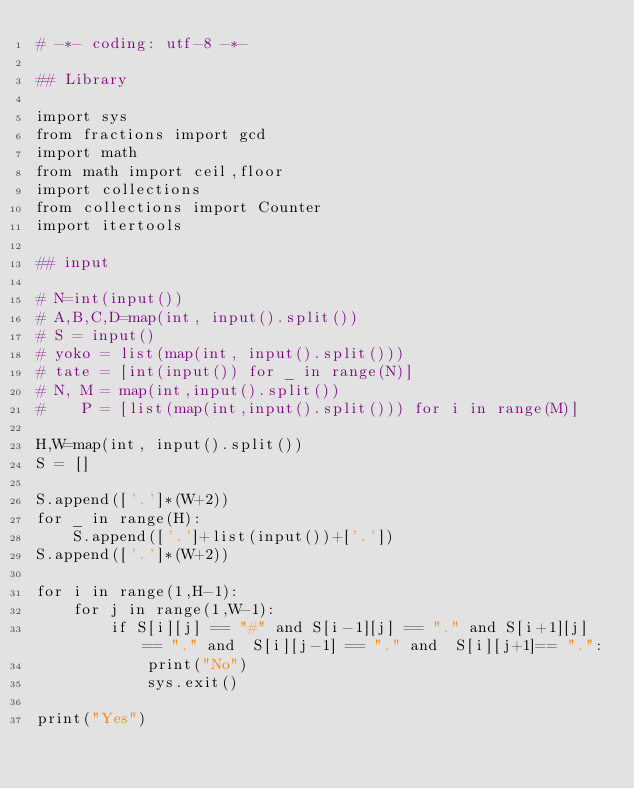Convert code to text. <code><loc_0><loc_0><loc_500><loc_500><_Python_># -*- coding: utf-8 -*-
 
## Library
 
import sys
from fractions import gcd
import math
from math import ceil,floor
import collections
from collections import Counter
import itertools

## input
 
# N=int(input())
# A,B,C,D=map(int, input().split())
# S = input()
# yoko = list(map(int, input().split()))
# tate = [int(input()) for _ in range(N)]
# N, M = map(int,input().split()) 
#    P = [list(map(int,input().split())) for i in range(M)]
 
H,W=map(int, input().split())
S = []

S.append(['.']*(W+2))
for _ in range(H):
    S.append(['.']+list(input())+['.'])
S.append(['.']*(W+2))

for i in range(1,H-1):
    for j in range(1,W-1):
        if S[i][j] == "#" and S[i-1][j] == "." and S[i+1][j] == "." and  S[i][j-1] == "." and  S[i][j+1]== ".":
            print("No")
            sys.exit()

print("Yes")</code> 